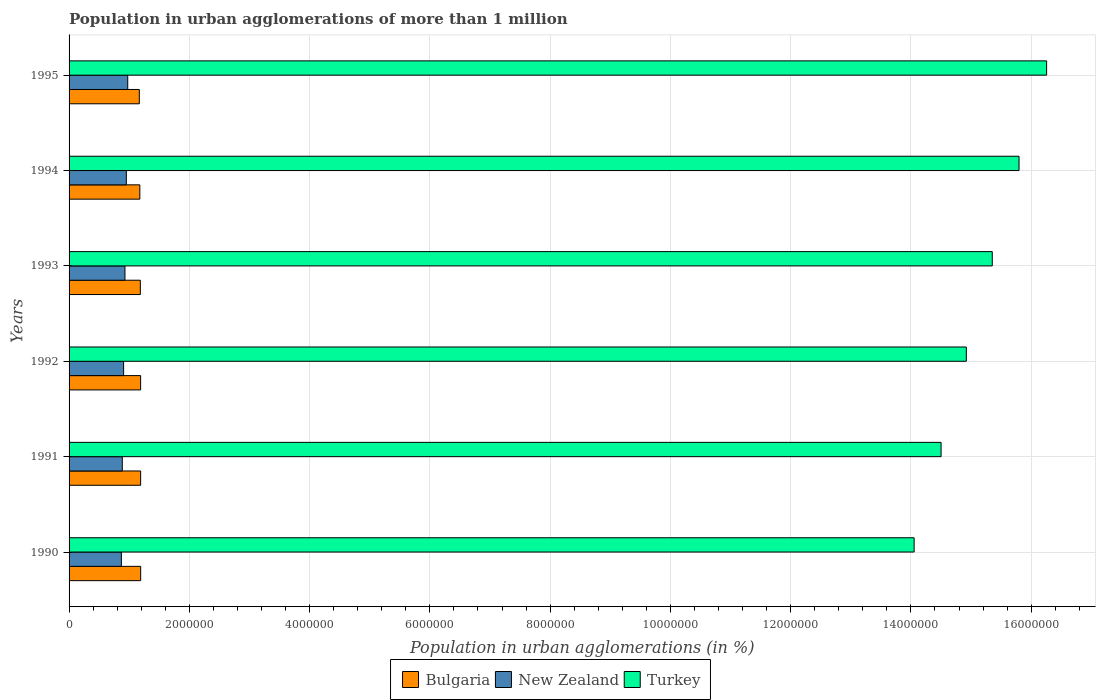Are the number of bars per tick equal to the number of legend labels?
Your answer should be very brief. Yes. Are the number of bars on each tick of the Y-axis equal?
Keep it short and to the point. Yes. How many bars are there on the 1st tick from the bottom?
Keep it short and to the point. 3. What is the label of the 2nd group of bars from the top?
Keep it short and to the point. 1994. In how many cases, is the number of bars for a given year not equal to the number of legend labels?
Provide a short and direct response. 0. What is the population in urban agglomerations in New Zealand in 1994?
Your response must be concise. 9.52e+05. Across all years, what is the maximum population in urban agglomerations in New Zealand?
Your response must be concise. 9.76e+05. Across all years, what is the minimum population in urban agglomerations in New Zealand?
Your answer should be very brief. 8.70e+05. In which year was the population in urban agglomerations in New Zealand maximum?
Give a very brief answer. 1995. What is the total population in urban agglomerations in New Zealand in the graph?
Ensure brevity in your answer.  5.52e+06. What is the difference between the population in urban agglomerations in New Zealand in 1993 and that in 1995?
Make the answer very short. -4.63e+04. What is the difference between the population in urban agglomerations in Bulgaria in 1990 and the population in urban agglomerations in Turkey in 1991?
Make the answer very short. -1.33e+07. What is the average population in urban agglomerations in Turkey per year?
Offer a terse response. 1.51e+07. In the year 1993, what is the difference between the population in urban agglomerations in Bulgaria and population in urban agglomerations in New Zealand?
Give a very brief answer. 2.56e+05. In how many years, is the population in urban agglomerations in New Zealand greater than 14800000 %?
Ensure brevity in your answer.  0. What is the ratio of the population in urban agglomerations in Turkey in 1990 to that in 1993?
Keep it short and to the point. 0.92. Is the population in urban agglomerations in New Zealand in 1991 less than that in 1994?
Offer a very short reply. Yes. What is the difference between the highest and the second highest population in urban agglomerations in Turkey?
Make the answer very short. 4.59e+05. What is the difference between the highest and the lowest population in urban agglomerations in Turkey?
Give a very brief answer. 2.20e+06. What does the 2nd bar from the top in 1992 represents?
Make the answer very short. New Zealand. Is it the case that in every year, the sum of the population in urban agglomerations in New Zealand and population in urban agglomerations in Bulgaria is greater than the population in urban agglomerations in Turkey?
Offer a terse response. No. How many bars are there?
Provide a succinct answer. 18. Are the values on the major ticks of X-axis written in scientific E-notation?
Provide a succinct answer. No. Where does the legend appear in the graph?
Ensure brevity in your answer.  Bottom center. How many legend labels are there?
Provide a succinct answer. 3. What is the title of the graph?
Ensure brevity in your answer.  Population in urban agglomerations of more than 1 million. What is the label or title of the X-axis?
Your answer should be very brief. Population in urban agglomerations (in %). What is the label or title of the Y-axis?
Ensure brevity in your answer.  Years. What is the Population in urban agglomerations (in %) in Bulgaria in 1990?
Provide a short and direct response. 1.19e+06. What is the Population in urban agglomerations (in %) of New Zealand in 1990?
Make the answer very short. 8.70e+05. What is the Population in urban agglomerations (in %) of Turkey in 1990?
Offer a very short reply. 1.41e+07. What is the Population in urban agglomerations (in %) of Bulgaria in 1991?
Provide a short and direct response. 1.19e+06. What is the Population in urban agglomerations (in %) of New Zealand in 1991?
Offer a very short reply. 8.85e+05. What is the Population in urban agglomerations (in %) in Turkey in 1991?
Give a very brief answer. 1.45e+07. What is the Population in urban agglomerations (in %) in Bulgaria in 1992?
Provide a succinct answer. 1.19e+06. What is the Population in urban agglomerations (in %) of New Zealand in 1992?
Ensure brevity in your answer.  9.07e+05. What is the Population in urban agglomerations (in %) of Turkey in 1992?
Your answer should be compact. 1.49e+07. What is the Population in urban agglomerations (in %) in Bulgaria in 1993?
Keep it short and to the point. 1.18e+06. What is the Population in urban agglomerations (in %) in New Zealand in 1993?
Your response must be concise. 9.29e+05. What is the Population in urban agglomerations (in %) of Turkey in 1993?
Your answer should be very brief. 1.54e+07. What is the Population in urban agglomerations (in %) of Bulgaria in 1994?
Provide a short and direct response. 1.18e+06. What is the Population in urban agglomerations (in %) in New Zealand in 1994?
Keep it short and to the point. 9.52e+05. What is the Population in urban agglomerations (in %) of Turkey in 1994?
Offer a very short reply. 1.58e+07. What is the Population in urban agglomerations (in %) in Bulgaria in 1995?
Make the answer very short. 1.17e+06. What is the Population in urban agglomerations (in %) of New Zealand in 1995?
Your response must be concise. 9.76e+05. What is the Population in urban agglomerations (in %) in Turkey in 1995?
Offer a very short reply. 1.63e+07. Across all years, what is the maximum Population in urban agglomerations (in %) in Bulgaria?
Ensure brevity in your answer.  1.19e+06. Across all years, what is the maximum Population in urban agglomerations (in %) of New Zealand?
Ensure brevity in your answer.  9.76e+05. Across all years, what is the maximum Population in urban agglomerations (in %) of Turkey?
Offer a terse response. 1.63e+07. Across all years, what is the minimum Population in urban agglomerations (in %) of Bulgaria?
Your answer should be compact. 1.17e+06. Across all years, what is the minimum Population in urban agglomerations (in %) of New Zealand?
Your answer should be compact. 8.70e+05. Across all years, what is the minimum Population in urban agglomerations (in %) of Turkey?
Your answer should be compact. 1.41e+07. What is the total Population in urban agglomerations (in %) in Bulgaria in the graph?
Offer a very short reply. 7.10e+06. What is the total Population in urban agglomerations (in %) of New Zealand in the graph?
Keep it short and to the point. 5.52e+06. What is the total Population in urban agglomerations (in %) of Turkey in the graph?
Your answer should be very brief. 9.09e+07. What is the difference between the Population in urban agglomerations (in %) in Bulgaria in 1990 and that in 1991?
Provide a succinct answer. 453. What is the difference between the Population in urban agglomerations (in %) in New Zealand in 1990 and that in 1991?
Your answer should be compact. -1.55e+04. What is the difference between the Population in urban agglomerations (in %) of Turkey in 1990 and that in 1991?
Your answer should be compact. -4.48e+05. What is the difference between the Population in urban agglomerations (in %) in Bulgaria in 1990 and that in 1992?
Your answer should be very brief. 907. What is the difference between the Population in urban agglomerations (in %) in New Zealand in 1990 and that in 1992?
Ensure brevity in your answer.  -3.73e+04. What is the difference between the Population in urban agglomerations (in %) of Turkey in 1990 and that in 1992?
Your answer should be compact. -8.68e+05. What is the difference between the Population in urban agglomerations (in %) of Bulgaria in 1990 and that in 1993?
Give a very brief answer. 5833. What is the difference between the Population in urban agglomerations (in %) in New Zealand in 1990 and that in 1993?
Make the answer very short. -5.96e+04. What is the difference between the Population in urban agglomerations (in %) in Turkey in 1990 and that in 1993?
Give a very brief answer. -1.30e+06. What is the difference between the Population in urban agglomerations (in %) of Bulgaria in 1990 and that in 1994?
Provide a succinct answer. 1.41e+04. What is the difference between the Population in urban agglomerations (in %) of New Zealand in 1990 and that in 1994?
Provide a succinct answer. -8.25e+04. What is the difference between the Population in urban agglomerations (in %) of Turkey in 1990 and that in 1994?
Your answer should be compact. -1.74e+06. What is the difference between the Population in urban agglomerations (in %) of Bulgaria in 1990 and that in 1995?
Offer a terse response. 2.23e+04. What is the difference between the Population in urban agglomerations (in %) in New Zealand in 1990 and that in 1995?
Offer a terse response. -1.06e+05. What is the difference between the Population in urban agglomerations (in %) in Turkey in 1990 and that in 1995?
Give a very brief answer. -2.20e+06. What is the difference between the Population in urban agglomerations (in %) of Bulgaria in 1991 and that in 1992?
Offer a very short reply. 454. What is the difference between the Population in urban agglomerations (in %) of New Zealand in 1991 and that in 1992?
Ensure brevity in your answer.  -2.18e+04. What is the difference between the Population in urban agglomerations (in %) of Turkey in 1991 and that in 1992?
Your answer should be compact. -4.20e+05. What is the difference between the Population in urban agglomerations (in %) in Bulgaria in 1991 and that in 1993?
Give a very brief answer. 5380. What is the difference between the Population in urban agglomerations (in %) in New Zealand in 1991 and that in 1993?
Ensure brevity in your answer.  -4.41e+04. What is the difference between the Population in urban agglomerations (in %) of Turkey in 1991 and that in 1993?
Your answer should be very brief. -8.51e+05. What is the difference between the Population in urban agglomerations (in %) of Bulgaria in 1991 and that in 1994?
Ensure brevity in your answer.  1.36e+04. What is the difference between the Population in urban agglomerations (in %) of New Zealand in 1991 and that in 1994?
Provide a short and direct response. -6.70e+04. What is the difference between the Population in urban agglomerations (in %) of Turkey in 1991 and that in 1994?
Keep it short and to the point. -1.30e+06. What is the difference between the Population in urban agglomerations (in %) in Bulgaria in 1991 and that in 1995?
Offer a very short reply. 2.18e+04. What is the difference between the Population in urban agglomerations (in %) of New Zealand in 1991 and that in 1995?
Provide a succinct answer. -9.04e+04. What is the difference between the Population in urban agglomerations (in %) in Turkey in 1991 and that in 1995?
Offer a very short reply. -1.76e+06. What is the difference between the Population in urban agglomerations (in %) in Bulgaria in 1992 and that in 1993?
Your response must be concise. 4926. What is the difference between the Population in urban agglomerations (in %) in New Zealand in 1992 and that in 1993?
Your answer should be compact. -2.23e+04. What is the difference between the Population in urban agglomerations (in %) in Turkey in 1992 and that in 1993?
Your answer should be very brief. -4.31e+05. What is the difference between the Population in urban agglomerations (in %) in Bulgaria in 1992 and that in 1994?
Offer a terse response. 1.32e+04. What is the difference between the Population in urban agglomerations (in %) of New Zealand in 1992 and that in 1994?
Provide a short and direct response. -4.52e+04. What is the difference between the Population in urban agglomerations (in %) of Turkey in 1992 and that in 1994?
Offer a very short reply. -8.77e+05. What is the difference between the Population in urban agglomerations (in %) in Bulgaria in 1992 and that in 1995?
Provide a succinct answer. 2.14e+04. What is the difference between the Population in urban agglomerations (in %) of New Zealand in 1992 and that in 1995?
Your answer should be very brief. -6.86e+04. What is the difference between the Population in urban agglomerations (in %) in Turkey in 1992 and that in 1995?
Your answer should be compact. -1.34e+06. What is the difference between the Population in urban agglomerations (in %) in Bulgaria in 1993 and that in 1994?
Keep it short and to the point. 8261. What is the difference between the Population in urban agglomerations (in %) of New Zealand in 1993 and that in 1994?
Give a very brief answer. -2.29e+04. What is the difference between the Population in urban agglomerations (in %) of Turkey in 1993 and that in 1994?
Your answer should be compact. -4.45e+05. What is the difference between the Population in urban agglomerations (in %) of Bulgaria in 1993 and that in 1995?
Keep it short and to the point. 1.65e+04. What is the difference between the Population in urban agglomerations (in %) of New Zealand in 1993 and that in 1995?
Offer a very short reply. -4.63e+04. What is the difference between the Population in urban agglomerations (in %) of Turkey in 1993 and that in 1995?
Provide a short and direct response. -9.04e+05. What is the difference between the Population in urban agglomerations (in %) in Bulgaria in 1994 and that in 1995?
Ensure brevity in your answer.  8203. What is the difference between the Population in urban agglomerations (in %) in New Zealand in 1994 and that in 1995?
Keep it short and to the point. -2.34e+04. What is the difference between the Population in urban agglomerations (in %) in Turkey in 1994 and that in 1995?
Provide a short and direct response. -4.59e+05. What is the difference between the Population in urban agglomerations (in %) of Bulgaria in 1990 and the Population in urban agglomerations (in %) of New Zealand in 1991?
Ensure brevity in your answer.  3.06e+05. What is the difference between the Population in urban agglomerations (in %) of Bulgaria in 1990 and the Population in urban agglomerations (in %) of Turkey in 1991?
Offer a terse response. -1.33e+07. What is the difference between the Population in urban agglomerations (in %) of New Zealand in 1990 and the Population in urban agglomerations (in %) of Turkey in 1991?
Make the answer very short. -1.36e+07. What is the difference between the Population in urban agglomerations (in %) in Bulgaria in 1990 and the Population in urban agglomerations (in %) in New Zealand in 1992?
Give a very brief answer. 2.84e+05. What is the difference between the Population in urban agglomerations (in %) of Bulgaria in 1990 and the Population in urban agglomerations (in %) of Turkey in 1992?
Provide a succinct answer. -1.37e+07. What is the difference between the Population in urban agglomerations (in %) in New Zealand in 1990 and the Population in urban agglomerations (in %) in Turkey in 1992?
Your answer should be very brief. -1.41e+07. What is the difference between the Population in urban agglomerations (in %) in Bulgaria in 1990 and the Population in urban agglomerations (in %) in New Zealand in 1993?
Offer a terse response. 2.61e+05. What is the difference between the Population in urban agglomerations (in %) in Bulgaria in 1990 and the Population in urban agglomerations (in %) in Turkey in 1993?
Offer a terse response. -1.42e+07. What is the difference between the Population in urban agglomerations (in %) of New Zealand in 1990 and the Population in urban agglomerations (in %) of Turkey in 1993?
Give a very brief answer. -1.45e+07. What is the difference between the Population in urban agglomerations (in %) in Bulgaria in 1990 and the Population in urban agglomerations (in %) in New Zealand in 1994?
Offer a very short reply. 2.39e+05. What is the difference between the Population in urban agglomerations (in %) in Bulgaria in 1990 and the Population in urban agglomerations (in %) in Turkey in 1994?
Make the answer very short. -1.46e+07. What is the difference between the Population in urban agglomerations (in %) in New Zealand in 1990 and the Population in urban agglomerations (in %) in Turkey in 1994?
Give a very brief answer. -1.49e+07. What is the difference between the Population in urban agglomerations (in %) of Bulgaria in 1990 and the Population in urban agglomerations (in %) of New Zealand in 1995?
Your answer should be compact. 2.15e+05. What is the difference between the Population in urban agglomerations (in %) in Bulgaria in 1990 and the Population in urban agglomerations (in %) in Turkey in 1995?
Provide a succinct answer. -1.51e+07. What is the difference between the Population in urban agglomerations (in %) in New Zealand in 1990 and the Population in urban agglomerations (in %) in Turkey in 1995?
Offer a terse response. -1.54e+07. What is the difference between the Population in urban agglomerations (in %) in Bulgaria in 1991 and the Population in urban agglomerations (in %) in New Zealand in 1992?
Give a very brief answer. 2.83e+05. What is the difference between the Population in urban agglomerations (in %) of Bulgaria in 1991 and the Population in urban agglomerations (in %) of Turkey in 1992?
Offer a terse response. -1.37e+07. What is the difference between the Population in urban agglomerations (in %) of New Zealand in 1991 and the Population in urban agglomerations (in %) of Turkey in 1992?
Provide a short and direct response. -1.40e+07. What is the difference between the Population in urban agglomerations (in %) in Bulgaria in 1991 and the Population in urban agglomerations (in %) in New Zealand in 1993?
Your answer should be very brief. 2.61e+05. What is the difference between the Population in urban agglomerations (in %) in Bulgaria in 1991 and the Population in urban agglomerations (in %) in Turkey in 1993?
Your response must be concise. -1.42e+07. What is the difference between the Population in urban agglomerations (in %) in New Zealand in 1991 and the Population in urban agglomerations (in %) in Turkey in 1993?
Offer a very short reply. -1.45e+07. What is the difference between the Population in urban agglomerations (in %) of Bulgaria in 1991 and the Population in urban agglomerations (in %) of New Zealand in 1994?
Provide a short and direct response. 2.38e+05. What is the difference between the Population in urban agglomerations (in %) in Bulgaria in 1991 and the Population in urban agglomerations (in %) in Turkey in 1994?
Your response must be concise. -1.46e+07. What is the difference between the Population in urban agglomerations (in %) in New Zealand in 1991 and the Population in urban agglomerations (in %) in Turkey in 1994?
Your answer should be very brief. -1.49e+07. What is the difference between the Population in urban agglomerations (in %) in Bulgaria in 1991 and the Population in urban agglomerations (in %) in New Zealand in 1995?
Your answer should be very brief. 2.15e+05. What is the difference between the Population in urban agglomerations (in %) in Bulgaria in 1991 and the Population in urban agglomerations (in %) in Turkey in 1995?
Ensure brevity in your answer.  -1.51e+07. What is the difference between the Population in urban agglomerations (in %) in New Zealand in 1991 and the Population in urban agglomerations (in %) in Turkey in 1995?
Offer a terse response. -1.54e+07. What is the difference between the Population in urban agglomerations (in %) in Bulgaria in 1992 and the Population in urban agglomerations (in %) in New Zealand in 1993?
Ensure brevity in your answer.  2.61e+05. What is the difference between the Population in urban agglomerations (in %) in Bulgaria in 1992 and the Population in urban agglomerations (in %) in Turkey in 1993?
Give a very brief answer. -1.42e+07. What is the difference between the Population in urban agglomerations (in %) in New Zealand in 1992 and the Population in urban agglomerations (in %) in Turkey in 1993?
Provide a short and direct response. -1.44e+07. What is the difference between the Population in urban agglomerations (in %) of Bulgaria in 1992 and the Population in urban agglomerations (in %) of New Zealand in 1994?
Offer a terse response. 2.38e+05. What is the difference between the Population in urban agglomerations (in %) in Bulgaria in 1992 and the Population in urban agglomerations (in %) in Turkey in 1994?
Your response must be concise. -1.46e+07. What is the difference between the Population in urban agglomerations (in %) of New Zealand in 1992 and the Population in urban agglomerations (in %) of Turkey in 1994?
Your answer should be very brief. -1.49e+07. What is the difference between the Population in urban agglomerations (in %) in Bulgaria in 1992 and the Population in urban agglomerations (in %) in New Zealand in 1995?
Your response must be concise. 2.14e+05. What is the difference between the Population in urban agglomerations (in %) of Bulgaria in 1992 and the Population in urban agglomerations (in %) of Turkey in 1995?
Keep it short and to the point. -1.51e+07. What is the difference between the Population in urban agglomerations (in %) of New Zealand in 1992 and the Population in urban agglomerations (in %) of Turkey in 1995?
Your answer should be very brief. -1.53e+07. What is the difference between the Population in urban agglomerations (in %) of Bulgaria in 1993 and the Population in urban agglomerations (in %) of New Zealand in 1994?
Your response must be concise. 2.33e+05. What is the difference between the Population in urban agglomerations (in %) of Bulgaria in 1993 and the Population in urban agglomerations (in %) of Turkey in 1994?
Your response must be concise. -1.46e+07. What is the difference between the Population in urban agglomerations (in %) in New Zealand in 1993 and the Population in urban agglomerations (in %) in Turkey in 1994?
Make the answer very short. -1.49e+07. What is the difference between the Population in urban agglomerations (in %) of Bulgaria in 1993 and the Population in urban agglomerations (in %) of New Zealand in 1995?
Provide a succinct answer. 2.09e+05. What is the difference between the Population in urban agglomerations (in %) of Bulgaria in 1993 and the Population in urban agglomerations (in %) of Turkey in 1995?
Make the answer very short. -1.51e+07. What is the difference between the Population in urban agglomerations (in %) in New Zealand in 1993 and the Population in urban agglomerations (in %) in Turkey in 1995?
Your answer should be very brief. -1.53e+07. What is the difference between the Population in urban agglomerations (in %) in Bulgaria in 1994 and the Population in urban agglomerations (in %) in New Zealand in 1995?
Offer a terse response. 2.01e+05. What is the difference between the Population in urban agglomerations (in %) in Bulgaria in 1994 and the Population in urban agglomerations (in %) in Turkey in 1995?
Your response must be concise. -1.51e+07. What is the difference between the Population in urban agglomerations (in %) of New Zealand in 1994 and the Population in urban agglomerations (in %) of Turkey in 1995?
Your answer should be very brief. -1.53e+07. What is the average Population in urban agglomerations (in %) of Bulgaria per year?
Your answer should be very brief. 1.18e+06. What is the average Population in urban agglomerations (in %) of New Zealand per year?
Provide a succinct answer. 9.20e+05. What is the average Population in urban agglomerations (in %) of Turkey per year?
Keep it short and to the point. 1.51e+07. In the year 1990, what is the difference between the Population in urban agglomerations (in %) of Bulgaria and Population in urban agglomerations (in %) of New Zealand?
Your response must be concise. 3.21e+05. In the year 1990, what is the difference between the Population in urban agglomerations (in %) in Bulgaria and Population in urban agglomerations (in %) in Turkey?
Give a very brief answer. -1.29e+07. In the year 1990, what is the difference between the Population in urban agglomerations (in %) of New Zealand and Population in urban agglomerations (in %) of Turkey?
Provide a short and direct response. -1.32e+07. In the year 1991, what is the difference between the Population in urban agglomerations (in %) in Bulgaria and Population in urban agglomerations (in %) in New Zealand?
Ensure brevity in your answer.  3.05e+05. In the year 1991, what is the difference between the Population in urban agglomerations (in %) in Bulgaria and Population in urban agglomerations (in %) in Turkey?
Give a very brief answer. -1.33e+07. In the year 1991, what is the difference between the Population in urban agglomerations (in %) in New Zealand and Population in urban agglomerations (in %) in Turkey?
Make the answer very short. -1.36e+07. In the year 1992, what is the difference between the Population in urban agglomerations (in %) of Bulgaria and Population in urban agglomerations (in %) of New Zealand?
Give a very brief answer. 2.83e+05. In the year 1992, what is the difference between the Population in urban agglomerations (in %) of Bulgaria and Population in urban agglomerations (in %) of Turkey?
Offer a very short reply. -1.37e+07. In the year 1992, what is the difference between the Population in urban agglomerations (in %) in New Zealand and Population in urban agglomerations (in %) in Turkey?
Give a very brief answer. -1.40e+07. In the year 1993, what is the difference between the Population in urban agglomerations (in %) in Bulgaria and Population in urban agglomerations (in %) in New Zealand?
Provide a short and direct response. 2.56e+05. In the year 1993, what is the difference between the Population in urban agglomerations (in %) of Bulgaria and Population in urban agglomerations (in %) of Turkey?
Offer a very short reply. -1.42e+07. In the year 1993, what is the difference between the Population in urban agglomerations (in %) of New Zealand and Population in urban agglomerations (in %) of Turkey?
Offer a terse response. -1.44e+07. In the year 1994, what is the difference between the Population in urban agglomerations (in %) of Bulgaria and Population in urban agglomerations (in %) of New Zealand?
Offer a terse response. 2.24e+05. In the year 1994, what is the difference between the Population in urban agglomerations (in %) in Bulgaria and Population in urban agglomerations (in %) in Turkey?
Provide a short and direct response. -1.46e+07. In the year 1994, what is the difference between the Population in urban agglomerations (in %) of New Zealand and Population in urban agglomerations (in %) of Turkey?
Provide a short and direct response. -1.48e+07. In the year 1995, what is the difference between the Population in urban agglomerations (in %) of Bulgaria and Population in urban agglomerations (in %) of New Zealand?
Offer a terse response. 1.93e+05. In the year 1995, what is the difference between the Population in urban agglomerations (in %) in Bulgaria and Population in urban agglomerations (in %) in Turkey?
Offer a very short reply. -1.51e+07. In the year 1995, what is the difference between the Population in urban agglomerations (in %) in New Zealand and Population in urban agglomerations (in %) in Turkey?
Ensure brevity in your answer.  -1.53e+07. What is the ratio of the Population in urban agglomerations (in %) of Bulgaria in 1990 to that in 1991?
Offer a terse response. 1. What is the ratio of the Population in urban agglomerations (in %) of New Zealand in 1990 to that in 1991?
Offer a terse response. 0.98. What is the ratio of the Population in urban agglomerations (in %) of Turkey in 1990 to that in 1991?
Make the answer very short. 0.97. What is the ratio of the Population in urban agglomerations (in %) in New Zealand in 1990 to that in 1992?
Ensure brevity in your answer.  0.96. What is the ratio of the Population in urban agglomerations (in %) of Turkey in 1990 to that in 1992?
Your answer should be very brief. 0.94. What is the ratio of the Population in urban agglomerations (in %) of New Zealand in 1990 to that in 1993?
Your answer should be very brief. 0.94. What is the ratio of the Population in urban agglomerations (in %) of Turkey in 1990 to that in 1993?
Your response must be concise. 0.92. What is the ratio of the Population in urban agglomerations (in %) in New Zealand in 1990 to that in 1994?
Offer a terse response. 0.91. What is the ratio of the Population in urban agglomerations (in %) of Turkey in 1990 to that in 1994?
Your answer should be compact. 0.89. What is the ratio of the Population in urban agglomerations (in %) of Bulgaria in 1990 to that in 1995?
Provide a succinct answer. 1.02. What is the ratio of the Population in urban agglomerations (in %) of New Zealand in 1990 to that in 1995?
Ensure brevity in your answer.  0.89. What is the ratio of the Population in urban agglomerations (in %) of Turkey in 1990 to that in 1995?
Keep it short and to the point. 0.86. What is the ratio of the Population in urban agglomerations (in %) of New Zealand in 1991 to that in 1992?
Make the answer very short. 0.98. What is the ratio of the Population in urban agglomerations (in %) in Turkey in 1991 to that in 1992?
Your response must be concise. 0.97. What is the ratio of the Population in urban agglomerations (in %) in Bulgaria in 1991 to that in 1993?
Ensure brevity in your answer.  1. What is the ratio of the Population in urban agglomerations (in %) in New Zealand in 1991 to that in 1993?
Provide a succinct answer. 0.95. What is the ratio of the Population in urban agglomerations (in %) of Turkey in 1991 to that in 1993?
Provide a succinct answer. 0.94. What is the ratio of the Population in urban agglomerations (in %) of Bulgaria in 1991 to that in 1994?
Your answer should be compact. 1.01. What is the ratio of the Population in urban agglomerations (in %) of New Zealand in 1991 to that in 1994?
Offer a terse response. 0.93. What is the ratio of the Population in urban agglomerations (in %) of Turkey in 1991 to that in 1994?
Give a very brief answer. 0.92. What is the ratio of the Population in urban agglomerations (in %) of Bulgaria in 1991 to that in 1995?
Provide a succinct answer. 1.02. What is the ratio of the Population in urban agglomerations (in %) in New Zealand in 1991 to that in 1995?
Your answer should be very brief. 0.91. What is the ratio of the Population in urban agglomerations (in %) of Turkey in 1991 to that in 1995?
Provide a short and direct response. 0.89. What is the ratio of the Population in urban agglomerations (in %) of Turkey in 1992 to that in 1993?
Ensure brevity in your answer.  0.97. What is the ratio of the Population in urban agglomerations (in %) of Bulgaria in 1992 to that in 1994?
Provide a short and direct response. 1.01. What is the ratio of the Population in urban agglomerations (in %) in New Zealand in 1992 to that in 1994?
Give a very brief answer. 0.95. What is the ratio of the Population in urban agglomerations (in %) of Turkey in 1992 to that in 1994?
Give a very brief answer. 0.94. What is the ratio of the Population in urban agglomerations (in %) in Bulgaria in 1992 to that in 1995?
Your answer should be compact. 1.02. What is the ratio of the Population in urban agglomerations (in %) of New Zealand in 1992 to that in 1995?
Your answer should be compact. 0.93. What is the ratio of the Population in urban agglomerations (in %) of Turkey in 1992 to that in 1995?
Offer a very short reply. 0.92. What is the ratio of the Population in urban agglomerations (in %) in Bulgaria in 1993 to that in 1994?
Offer a very short reply. 1.01. What is the ratio of the Population in urban agglomerations (in %) of New Zealand in 1993 to that in 1994?
Ensure brevity in your answer.  0.98. What is the ratio of the Population in urban agglomerations (in %) of Turkey in 1993 to that in 1994?
Give a very brief answer. 0.97. What is the ratio of the Population in urban agglomerations (in %) in Bulgaria in 1993 to that in 1995?
Make the answer very short. 1.01. What is the ratio of the Population in urban agglomerations (in %) in New Zealand in 1993 to that in 1995?
Offer a very short reply. 0.95. What is the ratio of the Population in urban agglomerations (in %) in Turkey in 1993 to that in 1995?
Your answer should be very brief. 0.94. What is the ratio of the Population in urban agglomerations (in %) in Turkey in 1994 to that in 1995?
Ensure brevity in your answer.  0.97. What is the difference between the highest and the second highest Population in urban agglomerations (in %) of Bulgaria?
Ensure brevity in your answer.  453. What is the difference between the highest and the second highest Population in urban agglomerations (in %) in New Zealand?
Keep it short and to the point. 2.34e+04. What is the difference between the highest and the second highest Population in urban agglomerations (in %) of Turkey?
Your answer should be very brief. 4.59e+05. What is the difference between the highest and the lowest Population in urban agglomerations (in %) of Bulgaria?
Offer a very short reply. 2.23e+04. What is the difference between the highest and the lowest Population in urban agglomerations (in %) of New Zealand?
Give a very brief answer. 1.06e+05. What is the difference between the highest and the lowest Population in urban agglomerations (in %) of Turkey?
Provide a short and direct response. 2.20e+06. 